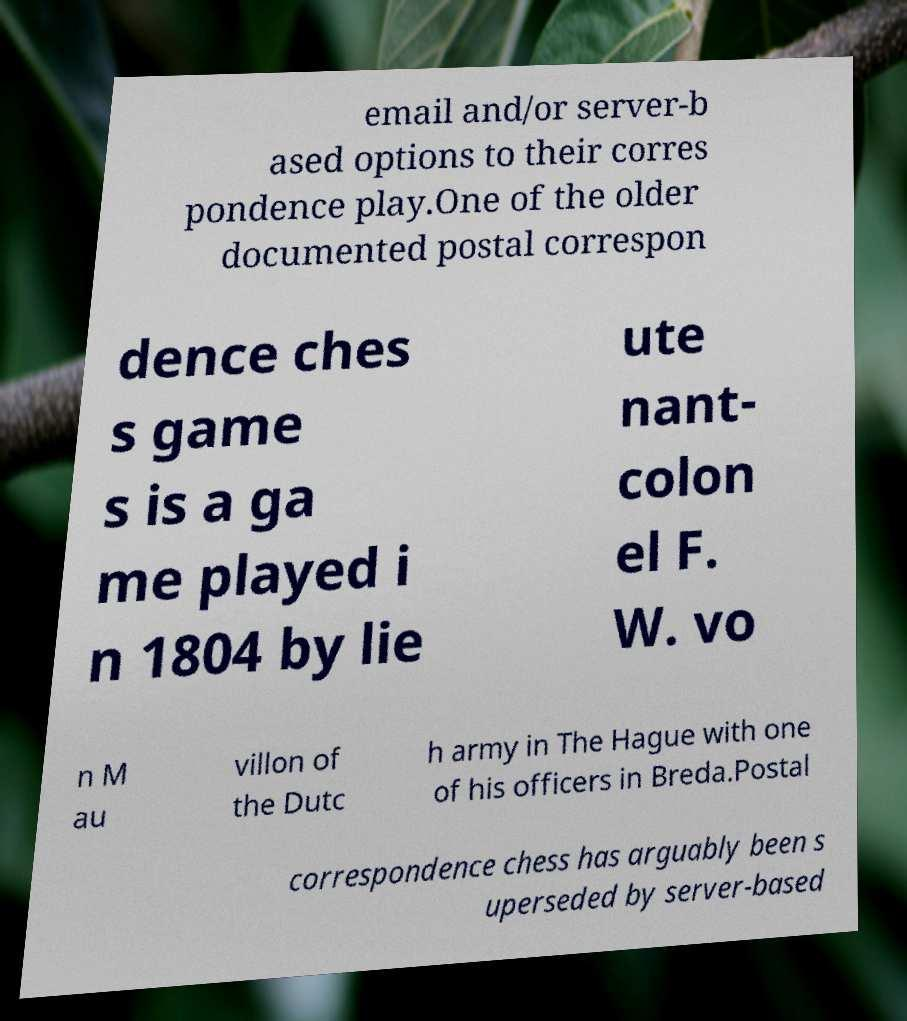Can you accurately transcribe the text from the provided image for me? email and/or server-b ased options to their corres pondence play.One of the older documented postal correspon dence ches s game s is a ga me played i n 1804 by lie ute nant- colon el F. W. vo n M au villon of the Dutc h army in The Hague with one of his officers in Breda.Postal correspondence chess has arguably been s uperseded by server-based 